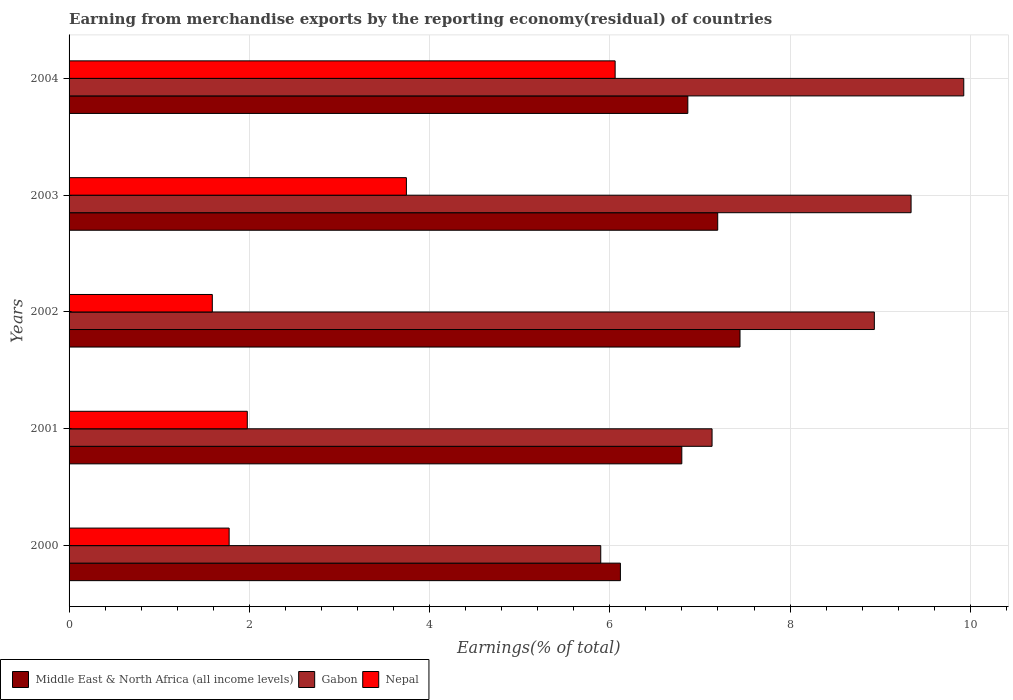How many different coloured bars are there?
Provide a short and direct response. 3. How many groups of bars are there?
Provide a short and direct response. 5. Are the number of bars per tick equal to the number of legend labels?
Provide a short and direct response. Yes. How many bars are there on the 3rd tick from the top?
Give a very brief answer. 3. In how many cases, is the number of bars for a given year not equal to the number of legend labels?
Keep it short and to the point. 0. What is the percentage of amount earned from merchandise exports in Middle East & North Africa (all income levels) in 2004?
Provide a succinct answer. 6.87. Across all years, what is the maximum percentage of amount earned from merchandise exports in Middle East & North Africa (all income levels)?
Provide a succinct answer. 7.44. Across all years, what is the minimum percentage of amount earned from merchandise exports in Gabon?
Give a very brief answer. 5.9. In which year was the percentage of amount earned from merchandise exports in Gabon maximum?
Offer a very short reply. 2004. In which year was the percentage of amount earned from merchandise exports in Middle East & North Africa (all income levels) minimum?
Your answer should be compact. 2000. What is the total percentage of amount earned from merchandise exports in Gabon in the graph?
Provide a succinct answer. 41.24. What is the difference between the percentage of amount earned from merchandise exports in Nepal in 2000 and that in 2002?
Offer a very short reply. 0.19. What is the difference between the percentage of amount earned from merchandise exports in Middle East & North Africa (all income levels) in 2001 and the percentage of amount earned from merchandise exports in Gabon in 2003?
Ensure brevity in your answer.  -2.54. What is the average percentage of amount earned from merchandise exports in Nepal per year?
Your response must be concise. 3.03. In the year 2000, what is the difference between the percentage of amount earned from merchandise exports in Middle East & North Africa (all income levels) and percentage of amount earned from merchandise exports in Nepal?
Ensure brevity in your answer.  4.34. In how many years, is the percentage of amount earned from merchandise exports in Gabon greater than 1.2000000000000002 %?
Offer a very short reply. 5. What is the ratio of the percentage of amount earned from merchandise exports in Gabon in 2003 to that in 2004?
Give a very brief answer. 0.94. Is the difference between the percentage of amount earned from merchandise exports in Middle East & North Africa (all income levels) in 2001 and 2004 greater than the difference between the percentage of amount earned from merchandise exports in Nepal in 2001 and 2004?
Give a very brief answer. Yes. What is the difference between the highest and the second highest percentage of amount earned from merchandise exports in Nepal?
Ensure brevity in your answer.  2.32. What is the difference between the highest and the lowest percentage of amount earned from merchandise exports in Gabon?
Your answer should be compact. 4.03. In how many years, is the percentage of amount earned from merchandise exports in Middle East & North Africa (all income levels) greater than the average percentage of amount earned from merchandise exports in Middle East & North Africa (all income levels) taken over all years?
Ensure brevity in your answer.  2. Is the sum of the percentage of amount earned from merchandise exports in Middle East & North Africa (all income levels) in 2000 and 2002 greater than the maximum percentage of amount earned from merchandise exports in Nepal across all years?
Offer a very short reply. Yes. What does the 1st bar from the top in 2004 represents?
Provide a short and direct response. Nepal. What does the 3rd bar from the bottom in 2004 represents?
Ensure brevity in your answer.  Nepal. Is it the case that in every year, the sum of the percentage of amount earned from merchandise exports in Middle East & North Africa (all income levels) and percentage of amount earned from merchandise exports in Gabon is greater than the percentage of amount earned from merchandise exports in Nepal?
Provide a succinct answer. Yes. How many bars are there?
Your response must be concise. 15. How many years are there in the graph?
Ensure brevity in your answer.  5. What is the difference between two consecutive major ticks on the X-axis?
Keep it short and to the point. 2. Does the graph contain any zero values?
Your response must be concise. No. How are the legend labels stacked?
Offer a very short reply. Horizontal. What is the title of the graph?
Provide a succinct answer. Earning from merchandise exports by the reporting economy(residual) of countries. What is the label or title of the X-axis?
Ensure brevity in your answer.  Earnings(% of total). What is the Earnings(% of total) of Middle East & North Africa (all income levels) in 2000?
Your answer should be compact. 6.12. What is the Earnings(% of total) of Gabon in 2000?
Your answer should be very brief. 5.9. What is the Earnings(% of total) in Nepal in 2000?
Your response must be concise. 1.78. What is the Earnings(% of total) in Middle East & North Africa (all income levels) in 2001?
Provide a short and direct response. 6.8. What is the Earnings(% of total) in Gabon in 2001?
Make the answer very short. 7.13. What is the Earnings(% of total) of Nepal in 2001?
Offer a very short reply. 1.98. What is the Earnings(% of total) of Middle East & North Africa (all income levels) in 2002?
Offer a very short reply. 7.44. What is the Earnings(% of total) of Gabon in 2002?
Make the answer very short. 8.93. What is the Earnings(% of total) of Nepal in 2002?
Your answer should be very brief. 1.59. What is the Earnings(% of total) in Middle East & North Africa (all income levels) in 2003?
Provide a short and direct response. 7.2. What is the Earnings(% of total) in Gabon in 2003?
Your answer should be very brief. 9.34. What is the Earnings(% of total) in Nepal in 2003?
Keep it short and to the point. 3.74. What is the Earnings(% of total) in Middle East & North Africa (all income levels) in 2004?
Keep it short and to the point. 6.87. What is the Earnings(% of total) of Gabon in 2004?
Your answer should be very brief. 9.93. What is the Earnings(% of total) of Nepal in 2004?
Give a very brief answer. 6.06. Across all years, what is the maximum Earnings(% of total) in Middle East & North Africa (all income levels)?
Offer a terse response. 7.44. Across all years, what is the maximum Earnings(% of total) in Gabon?
Give a very brief answer. 9.93. Across all years, what is the maximum Earnings(% of total) in Nepal?
Keep it short and to the point. 6.06. Across all years, what is the minimum Earnings(% of total) of Middle East & North Africa (all income levels)?
Make the answer very short. 6.12. Across all years, what is the minimum Earnings(% of total) in Gabon?
Ensure brevity in your answer.  5.9. Across all years, what is the minimum Earnings(% of total) of Nepal?
Offer a very short reply. 1.59. What is the total Earnings(% of total) in Middle East & North Africa (all income levels) in the graph?
Offer a terse response. 34.42. What is the total Earnings(% of total) in Gabon in the graph?
Offer a terse response. 41.24. What is the total Earnings(% of total) of Nepal in the graph?
Ensure brevity in your answer.  15.14. What is the difference between the Earnings(% of total) in Middle East & North Africa (all income levels) in 2000 and that in 2001?
Your answer should be compact. -0.68. What is the difference between the Earnings(% of total) in Gabon in 2000 and that in 2001?
Your answer should be compact. -1.24. What is the difference between the Earnings(% of total) of Nepal in 2000 and that in 2001?
Offer a very short reply. -0.2. What is the difference between the Earnings(% of total) of Middle East & North Africa (all income levels) in 2000 and that in 2002?
Offer a terse response. -1.33. What is the difference between the Earnings(% of total) of Gabon in 2000 and that in 2002?
Ensure brevity in your answer.  -3.04. What is the difference between the Earnings(% of total) in Nepal in 2000 and that in 2002?
Make the answer very short. 0.19. What is the difference between the Earnings(% of total) of Middle East & North Africa (all income levels) in 2000 and that in 2003?
Offer a very short reply. -1.08. What is the difference between the Earnings(% of total) of Gabon in 2000 and that in 2003?
Your response must be concise. -3.44. What is the difference between the Earnings(% of total) of Nepal in 2000 and that in 2003?
Give a very brief answer. -1.97. What is the difference between the Earnings(% of total) in Middle East & North Africa (all income levels) in 2000 and that in 2004?
Offer a terse response. -0.75. What is the difference between the Earnings(% of total) in Gabon in 2000 and that in 2004?
Offer a very short reply. -4.03. What is the difference between the Earnings(% of total) of Nepal in 2000 and that in 2004?
Offer a very short reply. -4.28. What is the difference between the Earnings(% of total) of Middle East & North Africa (all income levels) in 2001 and that in 2002?
Your response must be concise. -0.65. What is the difference between the Earnings(% of total) of Gabon in 2001 and that in 2002?
Provide a succinct answer. -1.8. What is the difference between the Earnings(% of total) in Nepal in 2001 and that in 2002?
Give a very brief answer. 0.39. What is the difference between the Earnings(% of total) of Middle East & North Africa (all income levels) in 2001 and that in 2003?
Give a very brief answer. -0.4. What is the difference between the Earnings(% of total) of Gabon in 2001 and that in 2003?
Offer a very short reply. -2.21. What is the difference between the Earnings(% of total) of Nepal in 2001 and that in 2003?
Provide a short and direct response. -1.77. What is the difference between the Earnings(% of total) of Middle East & North Africa (all income levels) in 2001 and that in 2004?
Give a very brief answer. -0.07. What is the difference between the Earnings(% of total) in Gabon in 2001 and that in 2004?
Make the answer very short. -2.79. What is the difference between the Earnings(% of total) of Nepal in 2001 and that in 2004?
Provide a succinct answer. -4.08. What is the difference between the Earnings(% of total) of Middle East & North Africa (all income levels) in 2002 and that in 2003?
Your response must be concise. 0.25. What is the difference between the Earnings(% of total) in Gabon in 2002 and that in 2003?
Ensure brevity in your answer.  -0.41. What is the difference between the Earnings(% of total) of Nepal in 2002 and that in 2003?
Offer a terse response. -2.15. What is the difference between the Earnings(% of total) in Middle East & North Africa (all income levels) in 2002 and that in 2004?
Your answer should be compact. 0.58. What is the difference between the Earnings(% of total) in Gabon in 2002 and that in 2004?
Offer a terse response. -0.99. What is the difference between the Earnings(% of total) of Nepal in 2002 and that in 2004?
Offer a terse response. -4.47. What is the difference between the Earnings(% of total) in Middle East & North Africa (all income levels) in 2003 and that in 2004?
Offer a very short reply. 0.33. What is the difference between the Earnings(% of total) of Gabon in 2003 and that in 2004?
Offer a very short reply. -0.58. What is the difference between the Earnings(% of total) in Nepal in 2003 and that in 2004?
Keep it short and to the point. -2.32. What is the difference between the Earnings(% of total) of Middle East & North Africa (all income levels) in 2000 and the Earnings(% of total) of Gabon in 2001?
Offer a very short reply. -1.02. What is the difference between the Earnings(% of total) of Middle East & North Africa (all income levels) in 2000 and the Earnings(% of total) of Nepal in 2001?
Offer a terse response. 4.14. What is the difference between the Earnings(% of total) in Gabon in 2000 and the Earnings(% of total) in Nepal in 2001?
Your response must be concise. 3.92. What is the difference between the Earnings(% of total) of Middle East & North Africa (all income levels) in 2000 and the Earnings(% of total) of Gabon in 2002?
Your answer should be compact. -2.82. What is the difference between the Earnings(% of total) in Middle East & North Africa (all income levels) in 2000 and the Earnings(% of total) in Nepal in 2002?
Make the answer very short. 4.53. What is the difference between the Earnings(% of total) in Gabon in 2000 and the Earnings(% of total) in Nepal in 2002?
Your answer should be very brief. 4.31. What is the difference between the Earnings(% of total) in Middle East & North Africa (all income levels) in 2000 and the Earnings(% of total) in Gabon in 2003?
Your answer should be very brief. -3.23. What is the difference between the Earnings(% of total) of Middle East & North Africa (all income levels) in 2000 and the Earnings(% of total) of Nepal in 2003?
Make the answer very short. 2.37. What is the difference between the Earnings(% of total) in Gabon in 2000 and the Earnings(% of total) in Nepal in 2003?
Your answer should be very brief. 2.16. What is the difference between the Earnings(% of total) of Middle East & North Africa (all income levels) in 2000 and the Earnings(% of total) of Gabon in 2004?
Keep it short and to the point. -3.81. What is the difference between the Earnings(% of total) in Middle East & North Africa (all income levels) in 2000 and the Earnings(% of total) in Nepal in 2004?
Provide a short and direct response. 0.06. What is the difference between the Earnings(% of total) in Gabon in 2000 and the Earnings(% of total) in Nepal in 2004?
Offer a terse response. -0.16. What is the difference between the Earnings(% of total) of Middle East & North Africa (all income levels) in 2001 and the Earnings(% of total) of Gabon in 2002?
Offer a very short reply. -2.14. What is the difference between the Earnings(% of total) of Middle East & North Africa (all income levels) in 2001 and the Earnings(% of total) of Nepal in 2002?
Provide a short and direct response. 5.21. What is the difference between the Earnings(% of total) of Gabon in 2001 and the Earnings(% of total) of Nepal in 2002?
Offer a terse response. 5.54. What is the difference between the Earnings(% of total) in Middle East & North Africa (all income levels) in 2001 and the Earnings(% of total) in Gabon in 2003?
Keep it short and to the point. -2.54. What is the difference between the Earnings(% of total) of Middle East & North Africa (all income levels) in 2001 and the Earnings(% of total) of Nepal in 2003?
Give a very brief answer. 3.06. What is the difference between the Earnings(% of total) of Gabon in 2001 and the Earnings(% of total) of Nepal in 2003?
Give a very brief answer. 3.39. What is the difference between the Earnings(% of total) in Middle East & North Africa (all income levels) in 2001 and the Earnings(% of total) in Gabon in 2004?
Your answer should be compact. -3.13. What is the difference between the Earnings(% of total) in Middle East & North Africa (all income levels) in 2001 and the Earnings(% of total) in Nepal in 2004?
Give a very brief answer. 0.74. What is the difference between the Earnings(% of total) in Gabon in 2001 and the Earnings(% of total) in Nepal in 2004?
Your answer should be very brief. 1.08. What is the difference between the Earnings(% of total) in Middle East & North Africa (all income levels) in 2002 and the Earnings(% of total) in Gabon in 2003?
Ensure brevity in your answer.  -1.9. What is the difference between the Earnings(% of total) of Middle East & North Africa (all income levels) in 2002 and the Earnings(% of total) of Nepal in 2003?
Provide a short and direct response. 3.7. What is the difference between the Earnings(% of total) in Gabon in 2002 and the Earnings(% of total) in Nepal in 2003?
Offer a very short reply. 5.19. What is the difference between the Earnings(% of total) in Middle East & North Africa (all income levels) in 2002 and the Earnings(% of total) in Gabon in 2004?
Provide a succinct answer. -2.48. What is the difference between the Earnings(% of total) in Middle East & North Africa (all income levels) in 2002 and the Earnings(% of total) in Nepal in 2004?
Ensure brevity in your answer.  1.39. What is the difference between the Earnings(% of total) in Gabon in 2002 and the Earnings(% of total) in Nepal in 2004?
Keep it short and to the point. 2.88. What is the difference between the Earnings(% of total) in Middle East & North Africa (all income levels) in 2003 and the Earnings(% of total) in Gabon in 2004?
Provide a succinct answer. -2.73. What is the difference between the Earnings(% of total) in Middle East & North Africa (all income levels) in 2003 and the Earnings(% of total) in Nepal in 2004?
Your response must be concise. 1.14. What is the difference between the Earnings(% of total) of Gabon in 2003 and the Earnings(% of total) of Nepal in 2004?
Your answer should be compact. 3.28. What is the average Earnings(% of total) in Middle East & North Africa (all income levels) per year?
Make the answer very short. 6.88. What is the average Earnings(% of total) of Gabon per year?
Keep it short and to the point. 8.25. What is the average Earnings(% of total) in Nepal per year?
Your answer should be compact. 3.03. In the year 2000, what is the difference between the Earnings(% of total) of Middle East & North Africa (all income levels) and Earnings(% of total) of Gabon?
Your answer should be compact. 0.22. In the year 2000, what is the difference between the Earnings(% of total) in Middle East & North Africa (all income levels) and Earnings(% of total) in Nepal?
Keep it short and to the point. 4.34. In the year 2000, what is the difference between the Earnings(% of total) in Gabon and Earnings(% of total) in Nepal?
Give a very brief answer. 4.12. In the year 2001, what is the difference between the Earnings(% of total) in Middle East & North Africa (all income levels) and Earnings(% of total) in Gabon?
Offer a very short reply. -0.34. In the year 2001, what is the difference between the Earnings(% of total) in Middle East & North Africa (all income levels) and Earnings(% of total) in Nepal?
Provide a short and direct response. 4.82. In the year 2001, what is the difference between the Earnings(% of total) in Gabon and Earnings(% of total) in Nepal?
Give a very brief answer. 5.16. In the year 2002, what is the difference between the Earnings(% of total) of Middle East & North Africa (all income levels) and Earnings(% of total) of Gabon?
Offer a terse response. -1.49. In the year 2002, what is the difference between the Earnings(% of total) in Middle East & North Africa (all income levels) and Earnings(% of total) in Nepal?
Your answer should be very brief. 5.86. In the year 2002, what is the difference between the Earnings(% of total) of Gabon and Earnings(% of total) of Nepal?
Provide a short and direct response. 7.35. In the year 2003, what is the difference between the Earnings(% of total) in Middle East & North Africa (all income levels) and Earnings(% of total) in Gabon?
Ensure brevity in your answer.  -2.15. In the year 2003, what is the difference between the Earnings(% of total) of Middle East & North Africa (all income levels) and Earnings(% of total) of Nepal?
Your response must be concise. 3.45. In the year 2003, what is the difference between the Earnings(% of total) of Gabon and Earnings(% of total) of Nepal?
Give a very brief answer. 5.6. In the year 2004, what is the difference between the Earnings(% of total) in Middle East & North Africa (all income levels) and Earnings(% of total) in Gabon?
Provide a short and direct response. -3.06. In the year 2004, what is the difference between the Earnings(% of total) of Middle East & North Africa (all income levels) and Earnings(% of total) of Nepal?
Offer a terse response. 0.81. In the year 2004, what is the difference between the Earnings(% of total) in Gabon and Earnings(% of total) in Nepal?
Your answer should be very brief. 3.87. What is the ratio of the Earnings(% of total) of Middle East & North Africa (all income levels) in 2000 to that in 2001?
Ensure brevity in your answer.  0.9. What is the ratio of the Earnings(% of total) of Gabon in 2000 to that in 2001?
Provide a succinct answer. 0.83. What is the ratio of the Earnings(% of total) in Nepal in 2000 to that in 2001?
Your answer should be very brief. 0.9. What is the ratio of the Earnings(% of total) of Middle East & North Africa (all income levels) in 2000 to that in 2002?
Your answer should be compact. 0.82. What is the ratio of the Earnings(% of total) in Gabon in 2000 to that in 2002?
Ensure brevity in your answer.  0.66. What is the ratio of the Earnings(% of total) of Nepal in 2000 to that in 2002?
Provide a succinct answer. 1.12. What is the ratio of the Earnings(% of total) of Gabon in 2000 to that in 2003?
Give a very brief answer. 0.63. What is the ratio of the Earnings(% of total) of Nepal in 2000 to that in 2003?
Your response must be concise. 0.47. What is the ratio of the Earnings(% of total) of Middle East & North Africa (all income levels) in 2000 to that in 2004?
Your response must be concise. 0.89. What is the ratio of the Earnings(% of total) in Gabon in 2000 to that in 2004?
Your response must be concise. 0.59. What is the ratio of the Earnings(% of total) in Nepal in 2000 to that in 2004?
Provide a short and direct response. 0.29. What is the ratio of the Earnings(% of total) of Middle East & North Africa (all income levels) in 2001 to that in 2002?
Your response must be concise. 0.91. What is the ratio of the Earnings(% of total) of Gabon in 2001 to that in 2002?
Make the answer very short. 0.8. What is the ratio of the Earnings(% of total) in Nepal in 2001 to that in 2002?
Make the answer very short. 1.24. What is the ratio of the Earnings(% of total) in Middle East & North Africa (all income levels) in 2001 to that in 2003?
Your answer should be very brief. 0.94. What is the ratio of the Earnings(% of total) of Gabon in 2001 to that in 2003?
Your response must be concise. 0.76. What is the ratio of the Earnings(% of total) in Nepal in 2001 to that in 2003?
Your response must be concise. 0.53. What is the ratio of the Earnings(% of total) in Middle East & North Africa (all income levels) in 2001 to that in 2004?
Provide a short and direct response. 0.99. What is the ratio of the Earnings(% of total) of Gabon in 2001 to that in 2004?
Offer a very short reply. 0.72. What is the ratio of the Earnings(% of total) in Nepal in 2001 to that in 2004?
Keep it short and to the point. 0.33. What is the ratio of the Earnings(% of total) of Middle East & North Africa (all income levels) in 2002 to that in 2003?
Offer a terse response. 1.03. What is the ratio of the Earnings(% of total) of Gabon in 2002 to that in 2003?
Offer a very short reply. 0.96. What is the ratio of the Earnings(% of total) of Nepal in 2002 to that in 2003?
Your answer should be very brief. 0.42. What is the ratio of the Earnings(% of total) of Middle East & North Africa (all income levels) in 2002 to that in 2004?
Your answer should be compact. 1.08. What is the ratio of the Earnings(% of total) of Gabon in 2002 to that in 2004?
Give a very brief answer. 0.9. What is the ratio of the Earnings(% of total) in Nepal in 2002 to that in 2004?
Ensure brevity in your answer.  0.26. What is the ratio of the Earnings(% of total) in Middle East & North Africa (all income levels) in 2003 to that in 2004?
Offer a terse response. 1.05. What is the ratio of the Earnings(% of total) of Gabon in 2003 to that in 2004?
Give a very brief answer. 0.94. What is the ratio of the Earnings(% of total) of Nepal in 2003 to that in 2004?
Offer a terse response. 0.62. What is the difference between the highest and the second highest Earnings(% of total) in Middle East & North Africa (all income levels)?
Your response must be concise. 0.25. What is the difference between the highest and the second highest Earnings(% of total) in Gabon?
Provide a succinct answer. 0.58. What is the difference between the highest and the second highest Earnings(% of total) in Nepal?
Give a very brief answer. 2.32. What is the difference between the highest and the lowest Earnings(% of total) of Middle East & North Africa (all income levels)?
Provide a succinct answer. 1.33. What is the difference between the highest and the lowest Earnings(% of total) of Gabon?
Ensure brevity in your answer.  4.03. What is the difference between the highest and the lowest Earnings(% of total) of Nepal?
Offer a terse response. 4.47. 